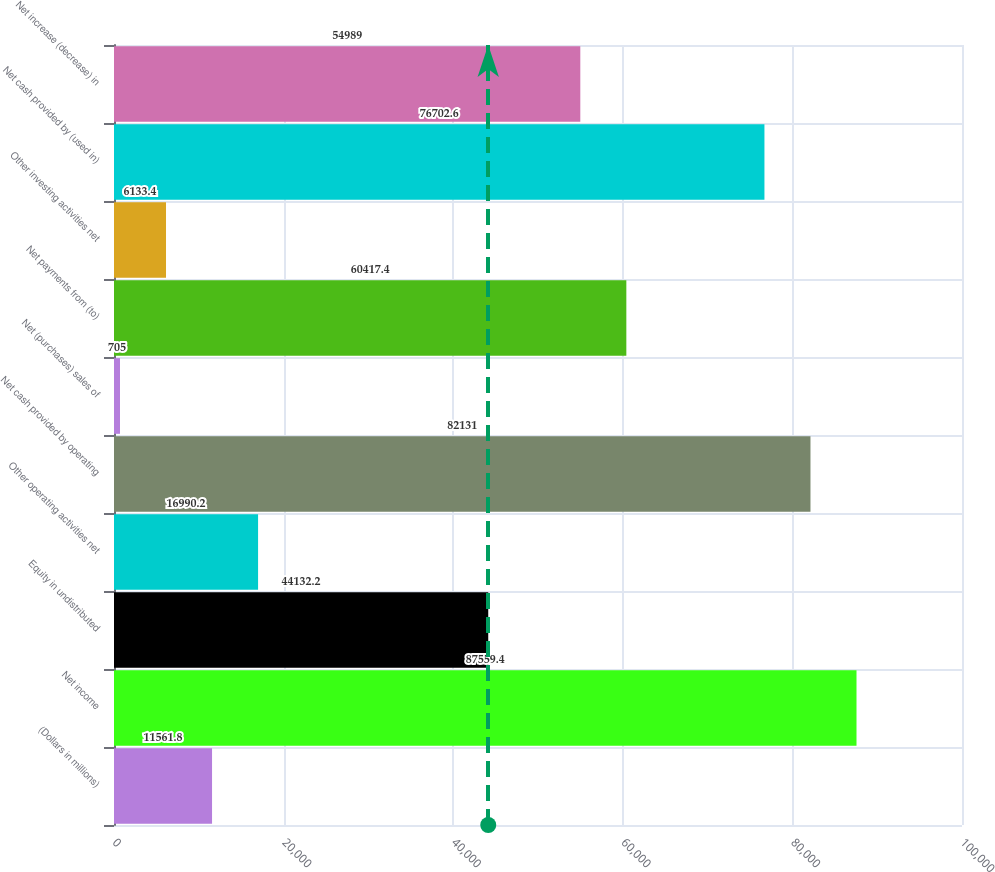Convert chart. <chart><loc_0><loc_0><loc_500><loc_500><bar_chart><fcel>(Dollars in millions)<fcel>Net income<fcel>Equity in undistributed<fcel>Other operating activities net<fcel>Net cash provided by operating<fcel>Net (purchases) sales of<fcel>Net payments from (to)<fcel>Other investing activities net<fcel>Net cash provided by (used in)<fcel>Net increase (decrease) in<nl><fcel>11561.8<fcel>87559.4<fcel>44132.2<fcel>16990.2<fcel>82131<fcel>705<fcel>60417.4<fcel>6133.4<fcel>76702.6<fcel>54989<nl></chart> 